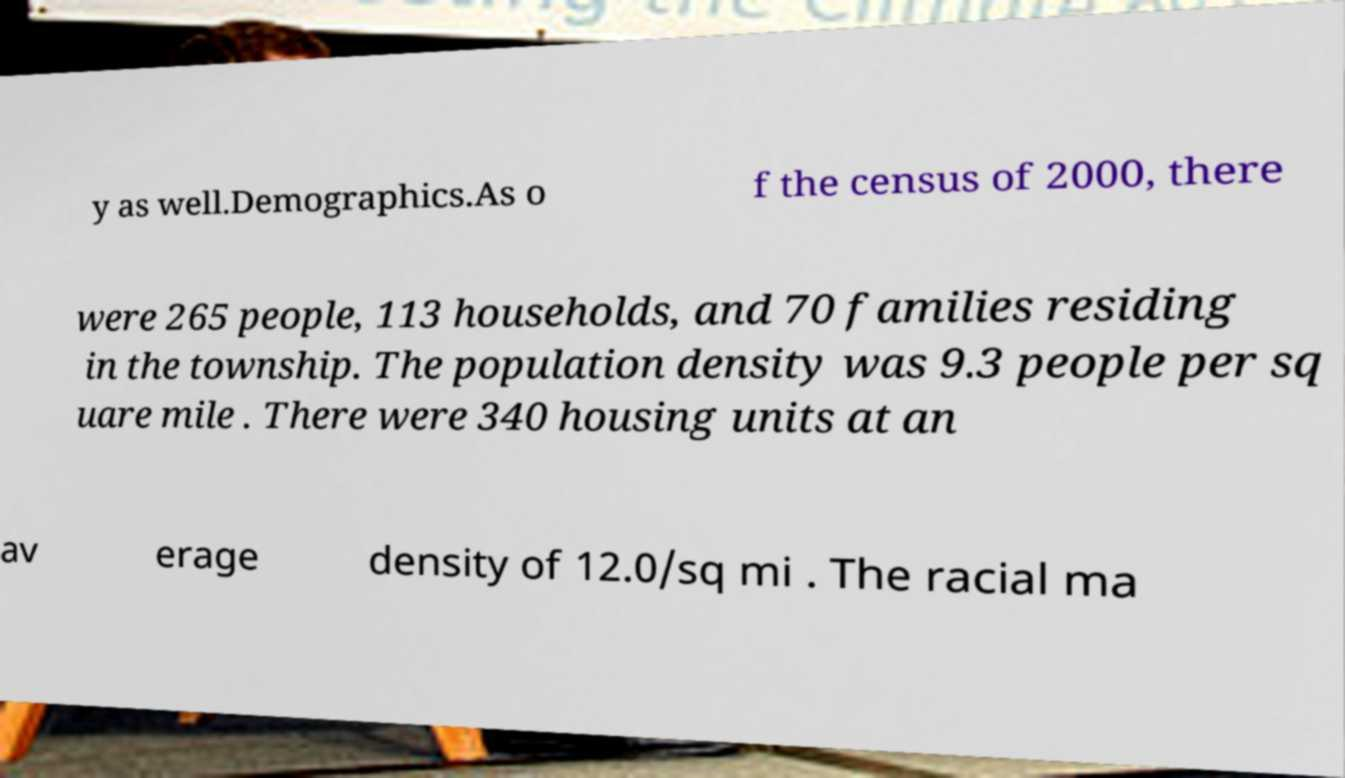Please identify and transcribe the text found in this image. y as well.Demographics.As o f the census of 2000, there were 265 people, 113 households, and 70 families residing in the township. The population density was 9.3 people per sq uare mile . There were 340 housing units at an av erage density of 12.0/sq mi . The racial ma 